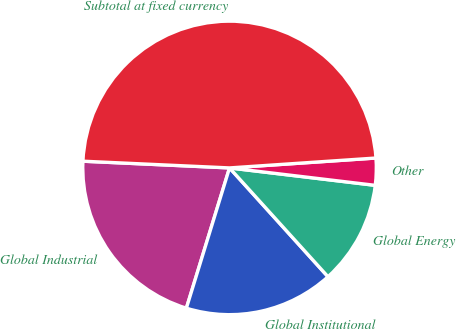Convert chart. <chart><loc_0><loc_0><loc_500><loc_500><pie_chart><fcel>Global Industrial<fcel>Global Institutional<fcel>Global Energy<fcel>Other<fcel>Subtotal at fixed currency<nl><fcel>20.98%<fcel>16.46%<fcel>11.4%<fcel>2.97%<fcel>48.2%<nl></chart> 